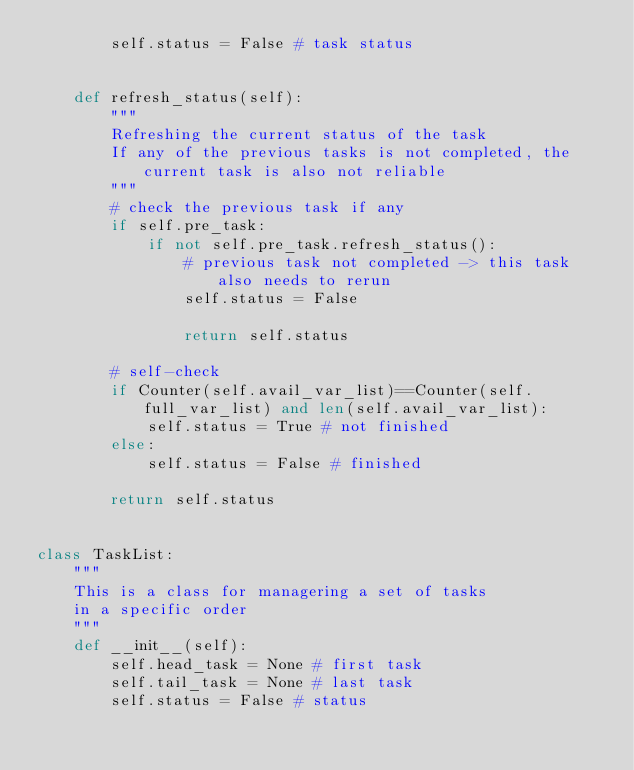<code> <loc_0><loc_0><loc_500><loc_500><_Python_>        self.status = False # task status

    
    def refresh_status(self):
        """
        Refreshing the current status of the task
        If any of the previous tasks is not completed, the current task is also not reliable
        """
        # check the previous task if any
        if self.pre_task:
            if not self.pre_task.refresh_status():
                # previous task not completed -> this task also needs to rerun
                self.status = False

                return self.status
    
        # self-check
        if Counter(self.avail_var_list)==Counter(self.full_var_list) and len(self.avail_var_list):
            self.status = True # not finished
        else:
            self.status = False # finished

        return self.status


class TaskList:
    """
    This is a class for managering a set of tasks
    in a specific order
    """
    def __init__(self):
        self.head_task = None # first task
        self.tail_task = None # last task
        self.status = False # status
</code> 